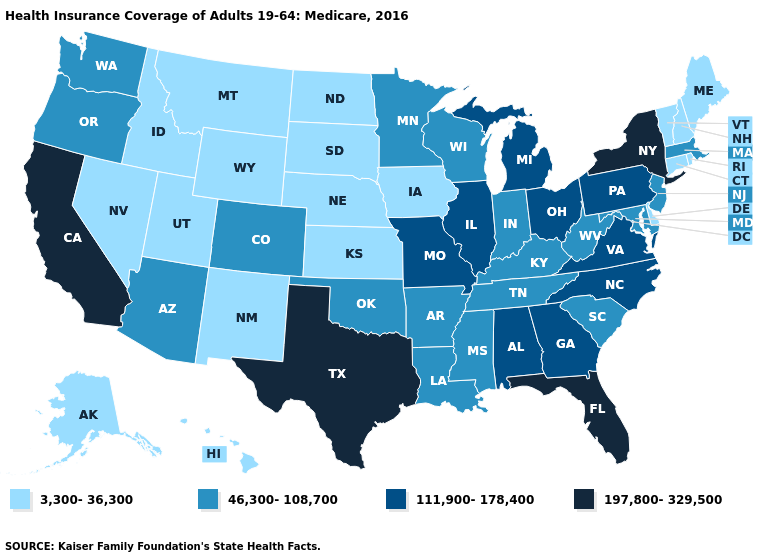What is the value of Kansas?
Concise answer only. 3,300-36,300. What is the value of Florida?
Answer briefly. 197,800-329,500. What is the value of Illinois?
Short answer required. 111,900-178,400. Which states hav the highest value in the MidWest?
Short answer required. Illinois, Michigan, Missouri, Ohio. Does the first symbol in the legend represent the smallest category?
Give a very brief answer. Yes. Which states have the highest value in the USA?
Short answer required. California, Florida, New York, Texas. What is the lowest value in the West?
Be succinct. 3,300-36,300. Name the states that have a value in the range 3,300-36,300?
Keep it brief. Alaska, Connecticut, Delaware, Hawaii, Idaho, Iowa, Kansas, Maine, Montana, Nebraska, Nevada, New Hampshire, New Mexico, North Dakota, Rhode Island, South Dakota, Utah, Vermont, Wyoming. Name the states that have a value in the range 197,800-329,500?
Short answer required. California, Florida, New York, Texas. What is the value of Alabama?
Keep it brief. 111,900-178,400. Which states hav the highest value in the South?
Short answer required. Florida, Texas. Does Delaware have a lower value than New Hampshire?
Keep it brief. No. Is the legend a continuous bar?
Quick response, please. No. What is the value of Indiana?
Write a very short answer. 46,300-108,700. Does Washington have the highest value in the West?
Quick response, please. No. 